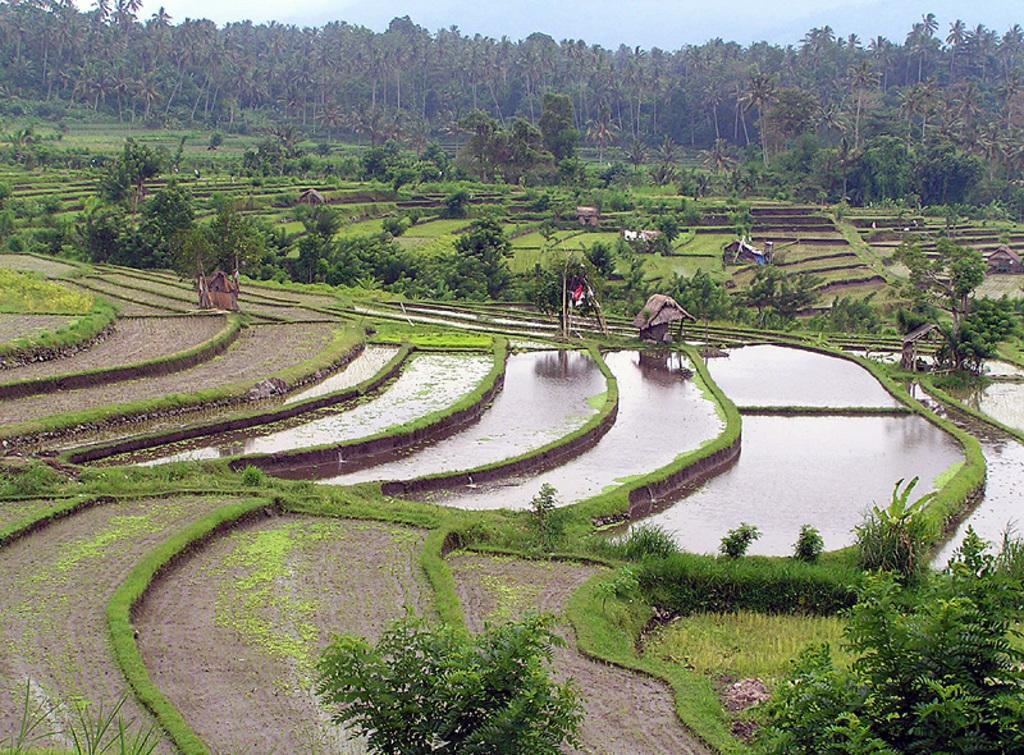What can be seen in the foreground of the image? In the foreground of the image, there is greenery, water, and huts. What is visible in the background of the image? In the background of the image, there are trees and the sky. Can you describe the natural elements present in the image? The image features greenery, water, and trees, which are all natural elements. Where can the rings be found in the image? There are no rings present in the image. What type of paper is being used to create the huts in the image? The image does not show any paper being used to create the huts; they are likely made of traditional building materials. 